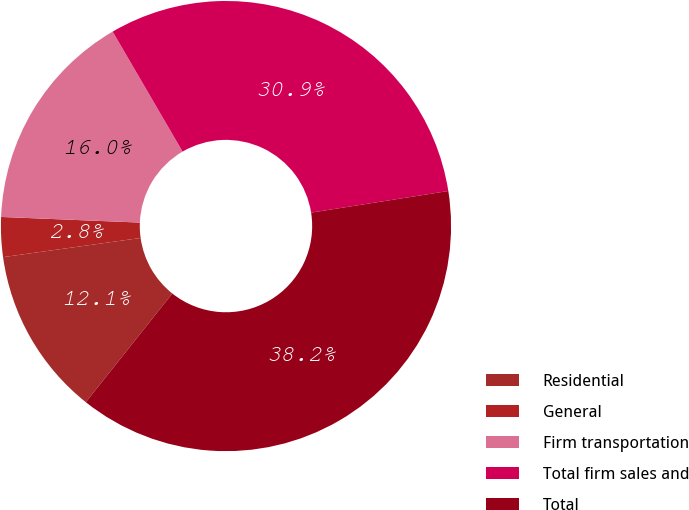<chart> <loc_0><loc_0><loc_500><loc_500><pie_chart><fcel>Residential<fcel>General<fcel>Firm transportation<fcel>Total firm sales and<fcel>Total<nl><fcel>12.1%<fcel>2.85%<fcel>15.96%<fcel>30.91%<fcel>38.19%<nl></chart> 